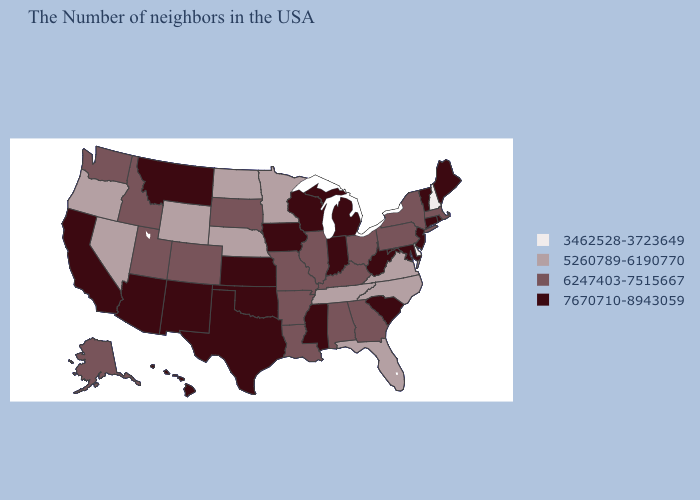Which states have the lowest value in the Northeast?
Write a very short answer. New Hampshire. Name the states that have a value in the range 5260789-6190770?
Answer briefly. Virginia, North Carolina, Florida, Tennessee, Minnesota, Nebraska, North Dakota, Wyoming, Nevada, Oregon. Does Louisiana have a lower value than Kansas?
Answer briefly. Yes. How many symbols are there in the legend?
Quick response, please. 4. Name the states that have a value in the range 5260789-6190770?
Keep it brief. Virginia, North Carolina, Florida, Tennessee, Minnesota, Nebraska, North Dakota, Wyoming, Nevada, Oregon. Is the legend a continuous bar?
Write a very short answer. No. Does Colorado have the lowest value in the West?
Quick response, please. No. Name the states that have a value in the range 3462528-3723649?
Answer briefly. New Hampshire, Delaware. Which states have the lowest value in the South?
Short answer required. Delaware. What is the value of Iowa?
Keep it brief. 7670710-8943059. Does New Jersey have the same value as Texas?
Keep it brief. Yes. Does Hawaii have a higher value than Tennessee?
Quick response, please. Yes. Name the states that have a value in the range 5260789-6190770?
Concise answer only. Virginia, North Carolina, Florida, Tennessee, Minnesota, Nebraska, North Dakota, Wyoming, Nevada, Oregon. What is the value of New Mexico?
Answer briefly. 7670710-8943059. What is the highest value in the USA?
Quick response, please. 7670710-8943059. 